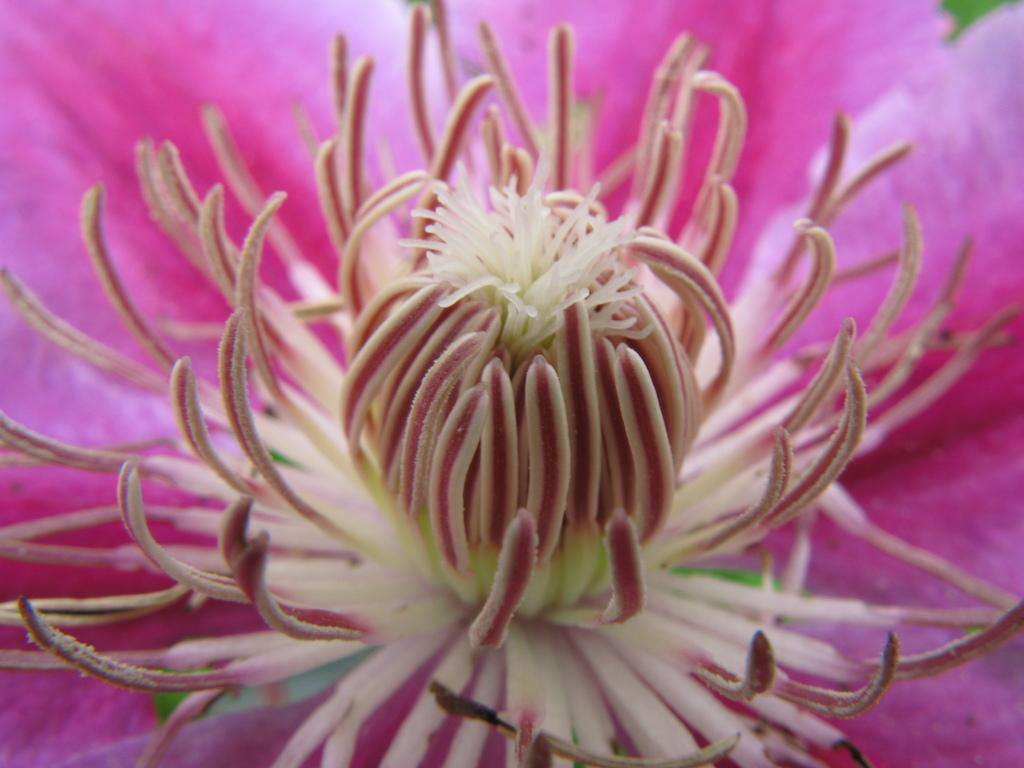What color is the flower in the image? The flower in the image is pink in color. What part of the flower is visible in the image? The flower has anthers visible in the image. How many nails are used to hold the flower in the image? There are no nails present in the image, as the flower is not attached to anything. 